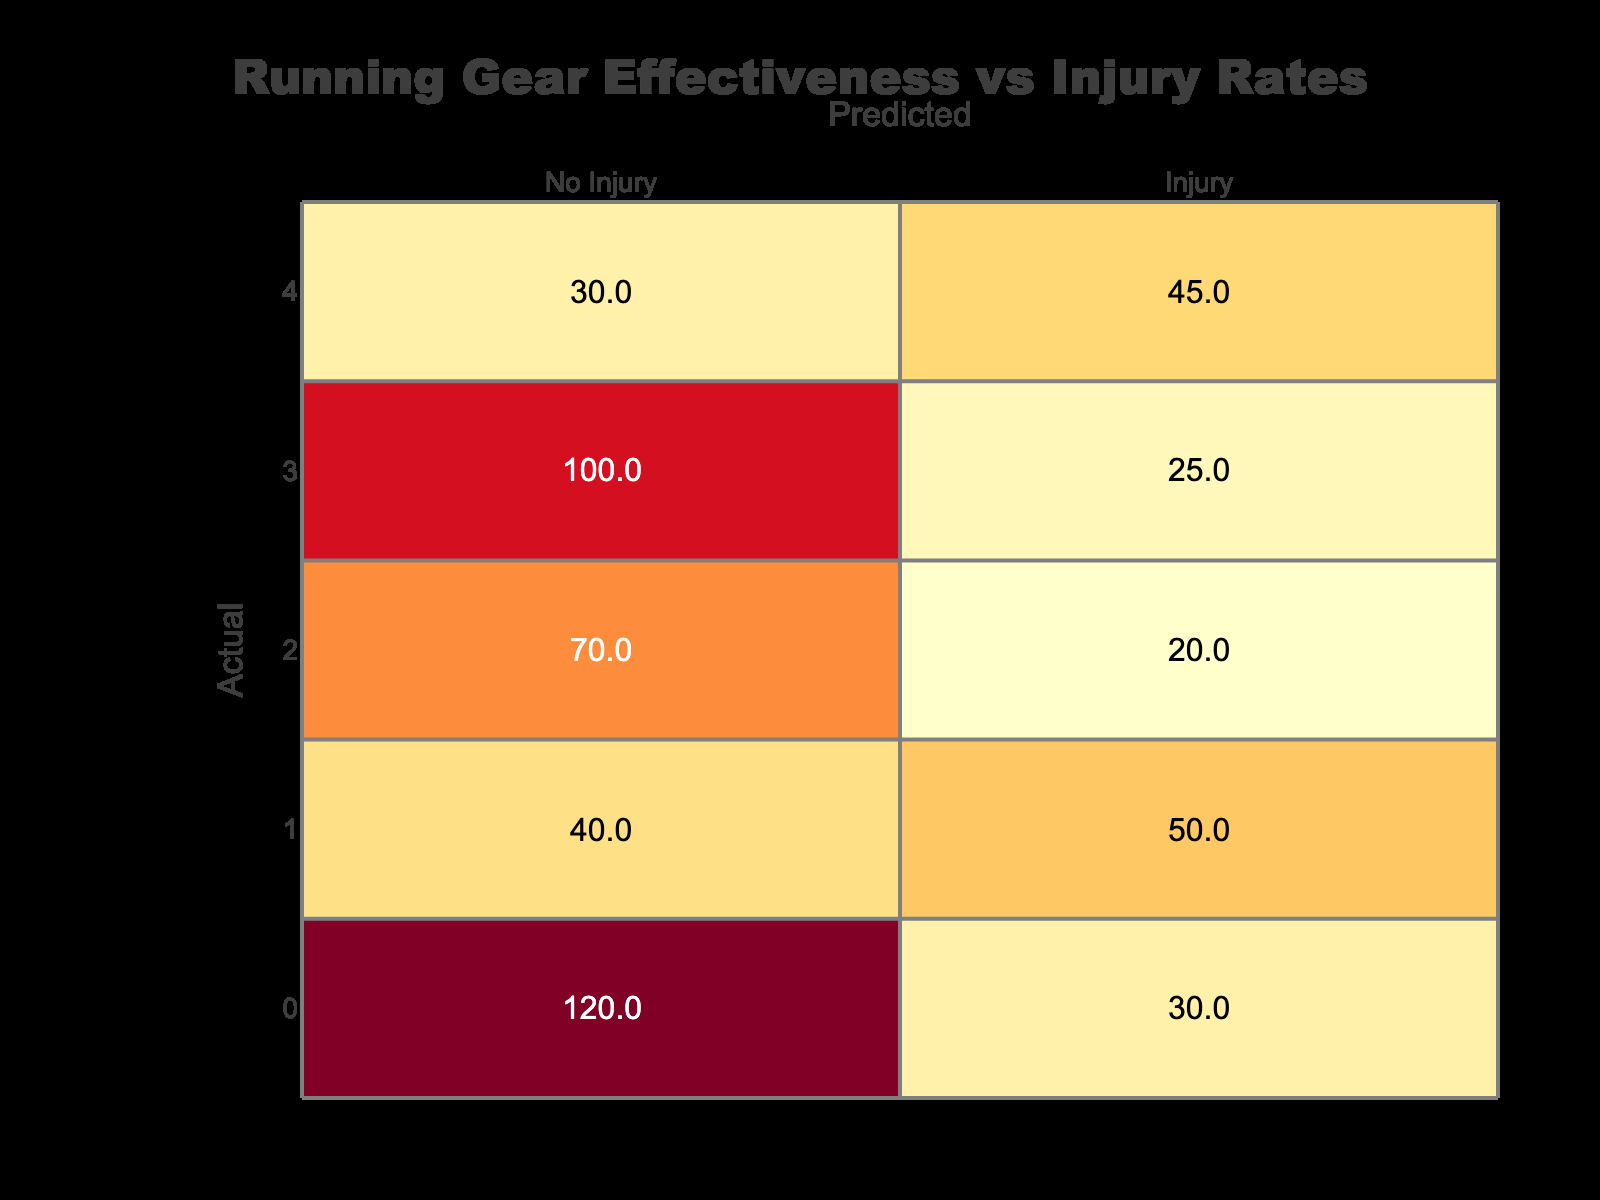What is the predicted number of injuries for old/used shoes? The table shows that the predicted number of injuries for old/used shoes is 45.
Answer: 45 What is the total number of athletes who experienced injuries while wearing supportive running shoes? The table indicates that the total number of injuries reported for supportive running shoes is 25.
Answer: 25 Which type of shoes has the highest predicted number of injuries? From the table, low-quality sneakers have the highest predicted number of injuries with 50.
Answer: Low-Quality Sneakers What is the total number of runners with no injuries across all shoe types? Summing the values for no injury across all shoe types gives (120 + 40 + 70 + 100 + 30) = 360.
Answer: 360 Are there more injuries predicted for old/used shoes than for high-quality sneakers? Yes, the predicted injuries for old/used shoes are 45, while for high-quality sneakers, it is 30.
Answer: Yes What percentage of runners using minimalist shoes are predicted to experience injuries? The predicted injuries for minimalist shoes are 20, and the total for minimalist shoes (20 + 70) = 90. Therefore, the percentage is (20/90) * 100 = 22.22%.
Answer: 22.22% What is the difference in the predicted number of injuries between low-quality sneakers and supportive running shoes? Low-quality sneakers have 50 predicted injuries, while supportive running shoes predict 25 injuries. The difference is 50 - 25 = 25.
Answer: 25 What is the average predicted number of injuries for all types of shoes combined? Summing the predicted injured patients (30 + 50 + 20 + 25 + 45 = 170), and there are 5 types of shoes, gives an average of 170/5 = 34.
Answer: 34 Is it true that supportive running shoes have a higher total number of no injuries compared to minimalist shoes? Yes, supportive running shoes have 100 no injuries while minimalist shoes have 70.
Answer: Yes 